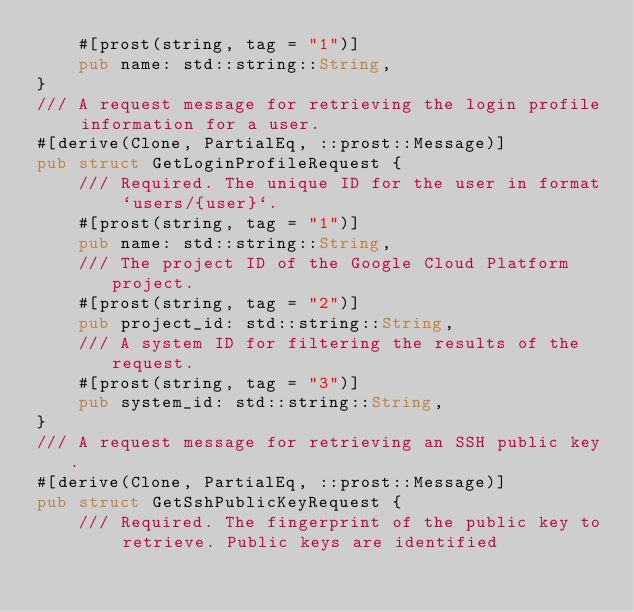<code> <loc_0><loc_0><loc_500><loc_500><_Rust_>    #[prost(string, tag = "1")]
    pub name: std::string::String,
}
/// A request message for retrieving the login profile information for a user.
#[derive(Clone, PartialEq, ::prost::Message)]
pub struct GetLoginProfileRequest {
    /// Required. The unique ID for the user in format `users/{user}`.
    #[prost(string, tag = "1")]
    pub name: std::string::String,
    /// The project ID of the Google Cloud Platform project.
    #[prost(string, tag = "2")]
    pub project_id: std::string::String,
    /// A system ID for filtering the results of the request.
    #[prost(string, tag = "3")]
    pub system_id: std::string::String,
}
/// A request message for retrieving an SSH public key.
#[derive(Clone, PartialEq, ::prost::Message)]
pub struct GetSshPublicKeyRequest {
    /// Required. The fingerprint of the public key to retrieve. Public keys are identified</code> 